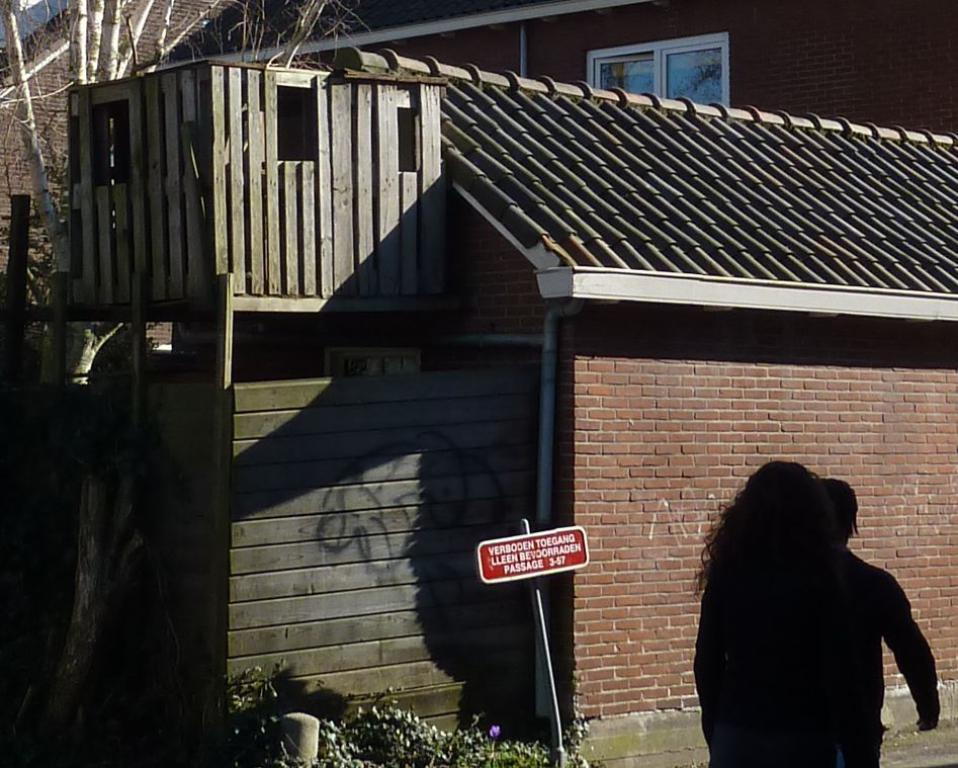What is located on the right side of the image? There is a sign board on the right side of the image. What can be seen on the road in the image? There are persons on the road. What is visible in the background of the image? There is a house and a tree in the background of the image. What type of shelf can be seen in the image? There is no shelf present in the image. What season is depicted in the image? The provided facts do not mention any seasonal details, so it cannot be determined from the image. 